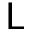Convert formula to latex. <formula><loc_0><loc_0><loc_500><loc_500>L</formula> 